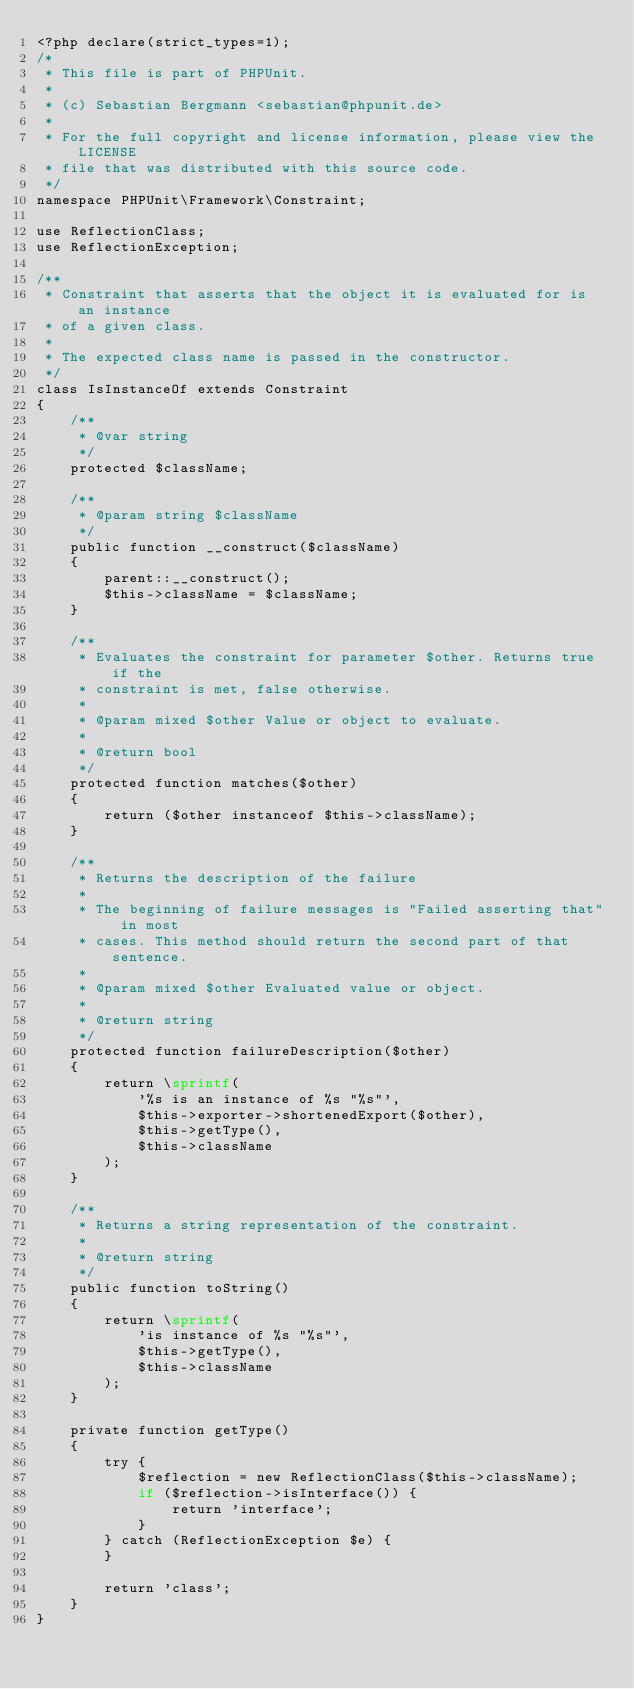<code> <loc_0><loc_0><loc_500><loc_500><_PHP_><?php declare(strict_types=1);
/*
 * This file is part of PHPUnit.
 *
 * (c) Sebastian Bergmann <sebastian@phpunit.de>
 *
 * For the full copyright and license information, please view the LICENSE
 * file that was distributed with this source code.
 */
namespace PHPUnit\Framework\Constraint;

use ReflectionClass;
use ReflectionException;

/**
 * Constraint that asserts that the object it is evaluated for is an instance
 * of a given class.
 *
 * The expected class name is passed in the constructor.
 */
class IsInstanceOf extends Constraint
{
    /**
     * @var string
     */
    protected $className;

    /**
     * @param string $className
     */
    public function __construct($className)
    {
        parent::__construct();
        $this->className = $className;
    }

    /**
     * Evaluates the constraint for parameter $other. Returns true if the
     * constraint is met, false otherwise.
     *
     * @param mixed $other Value or object to evaluate.
     *
     * @return bool
     */
    protected function matches($other)
    {
        return ($other instanceof $this->className);
    }

    /**
     * Returns the description of the failure
     *
     * The beginning of failure messages is "Failed asserting that" in most
     * cases. This method should return the second part of that sentence.
     *
     * @param mixed $other Evaluated value or object.
     *
     * @return string
     */
    protected function failureDescription($other)
    {
        return \sprintf(
            '%s is an instance of %s "%s"',
            $this->exporter->shortenedExport($other),
            $this->getType(),
            $this->className
        );
    }

    /**
     * Returns a string representation of the constraint.
     *
     * @return string
     */
    public function toString()
    {
        return \sprintf(
            'is instance of %s "%s"',
            $this->getType(),
            $this->className
        );
    }

    private function getType()
    {
        try {
            $reflection = new ReflectionClass($this->className);
            if ($reflection->isInterface()) {
                return 'interface';
            }
        } catch (ReflectionException $e) {
        }

        return 'class';
    }
}
</code> 